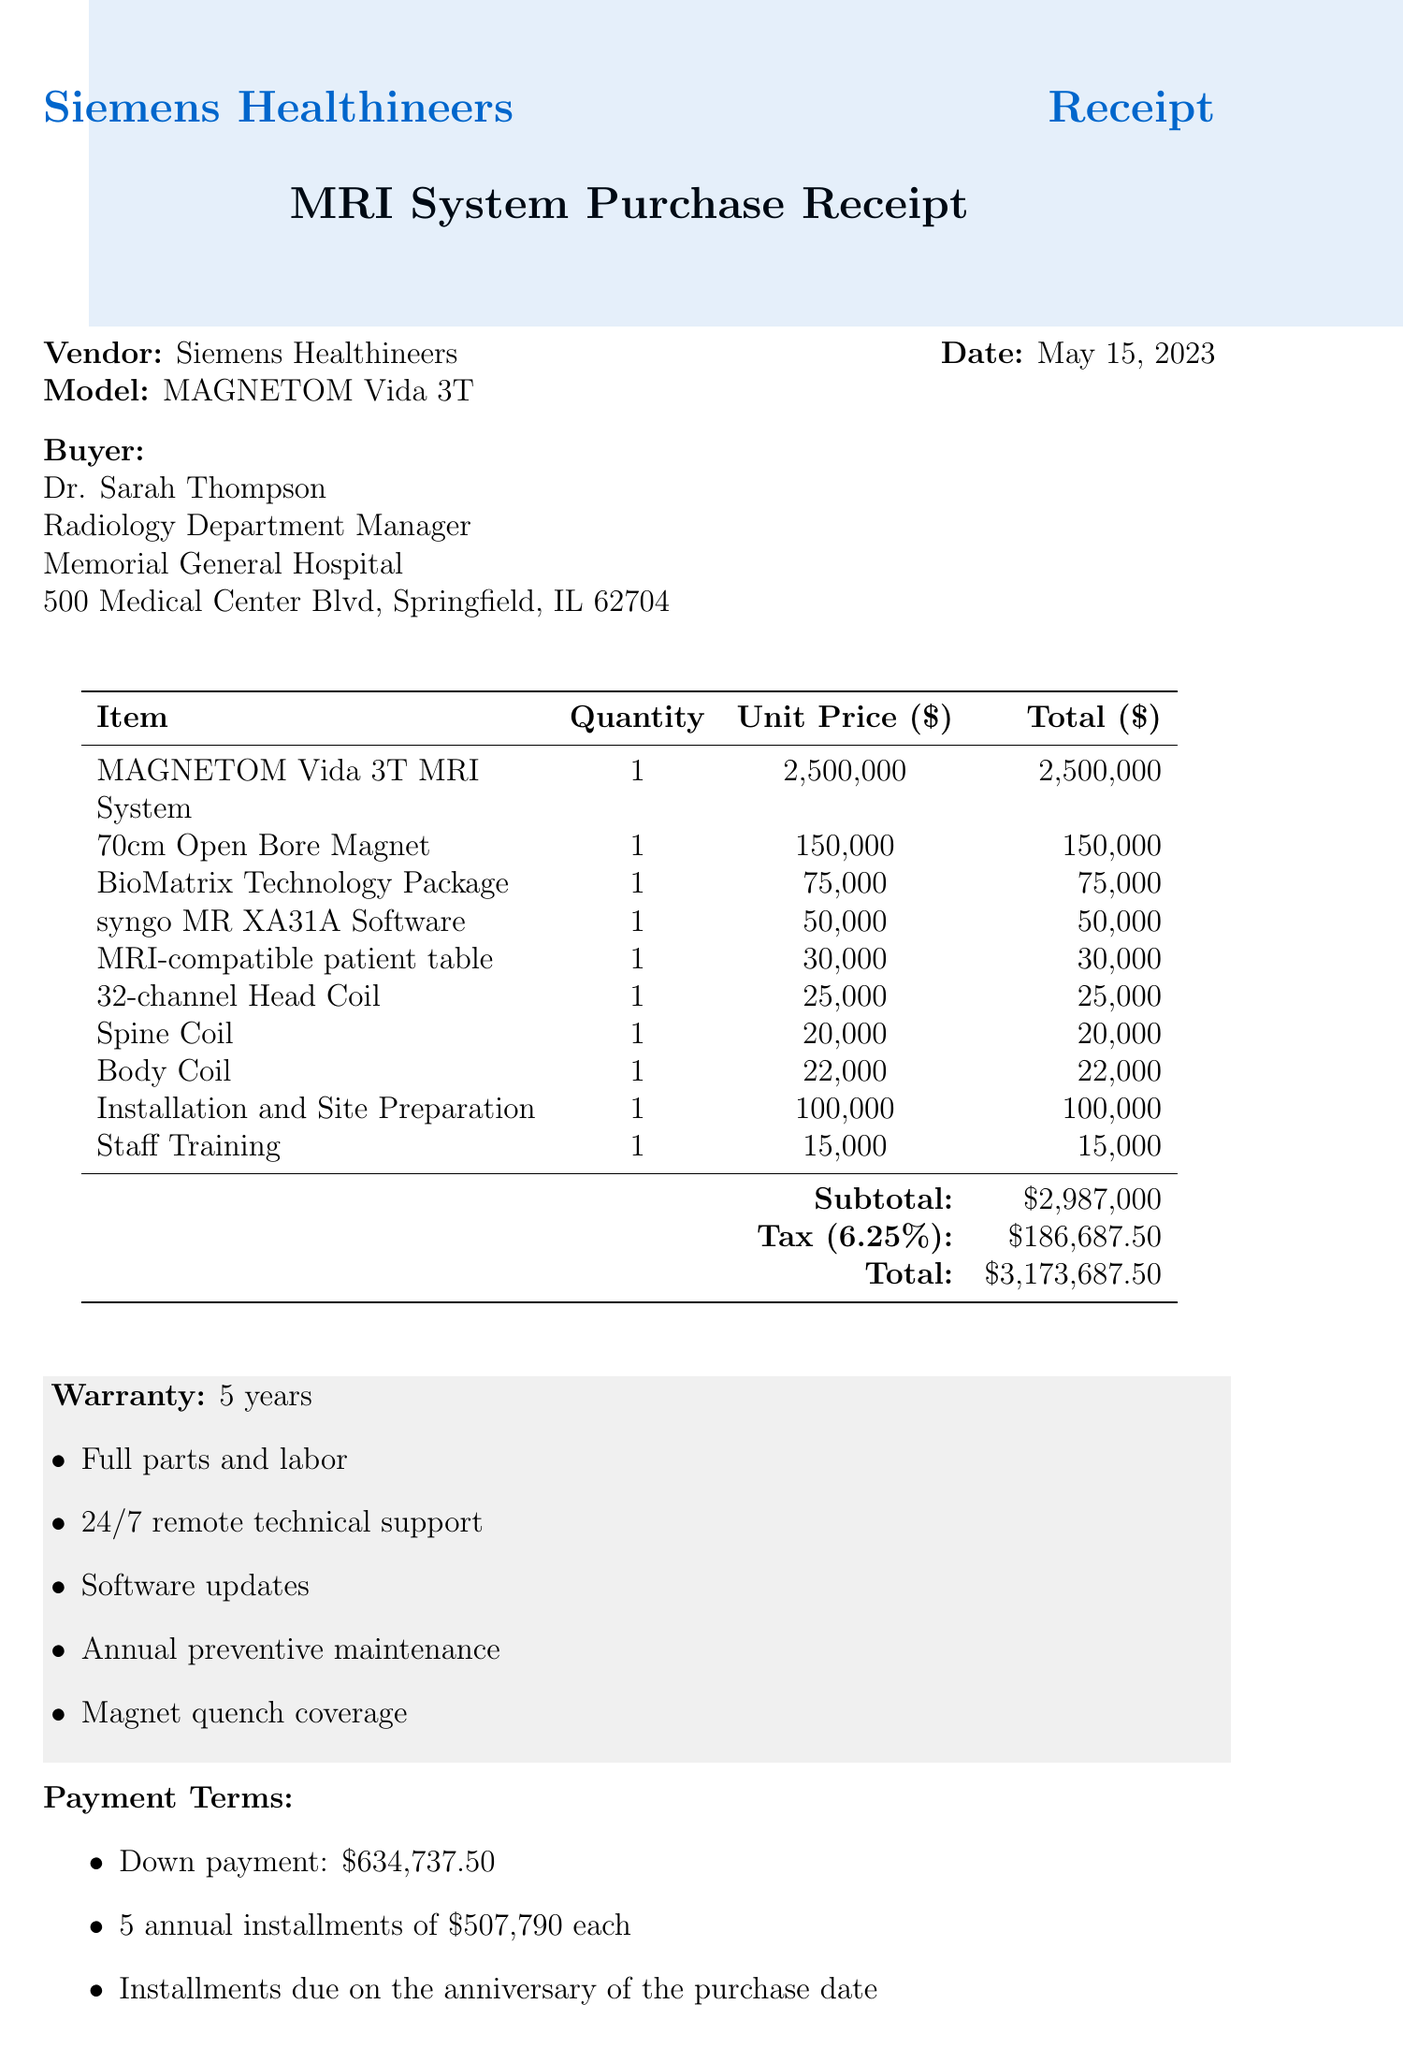what is the purchase date? The purchase date is explicitly stated in the document as the date of the transaction, which is May 15, 2023.
Answer: May 15, 2023 what is the total amount of the purchase? The total amount is the final figure summarized at the end of the document, including the subtotal and tax, which is $3,173,687.50.
Answer: $3,173,687.50 who is the buyer? The buyer's details are provided in the document, where it names Dr. Sarah Thompson as the Radiology Department Manager.
Answer: Dr. Sarah Thompson how long is the warranty duration? The warranty duration is mentioned in the warranty section as lasting for 5 years.
Answer: 5 years what is the down payment required? The down payment amount is clearly listed in the payment terms section, which states it is $634,737.50.
Answer: $634,737.50 how many items are listed for purchase? The document itemizes each purchased item in a table; there are 10 items listed.
Answer: 10 items what type of coils are included with the MRI system? The document specifically lists two types of coils included: 32-channel Head Coil and Spine Coil.
Answer: 32-channel Head Coil and Spine Coil what are the exclusions in the warranty? The document notes the exclusions in the warranty details, specifically mentioning damage due to misuse or neglect and consumables.
Answer: Damage due to misuse or neglect, Consumables what is the trade-in credit amount applied? The trade-in credit is mentioned in the additional notes section and is stated as $200,000 for the existing GE Signa 1.5T MRI system.
Answer: $200,000 